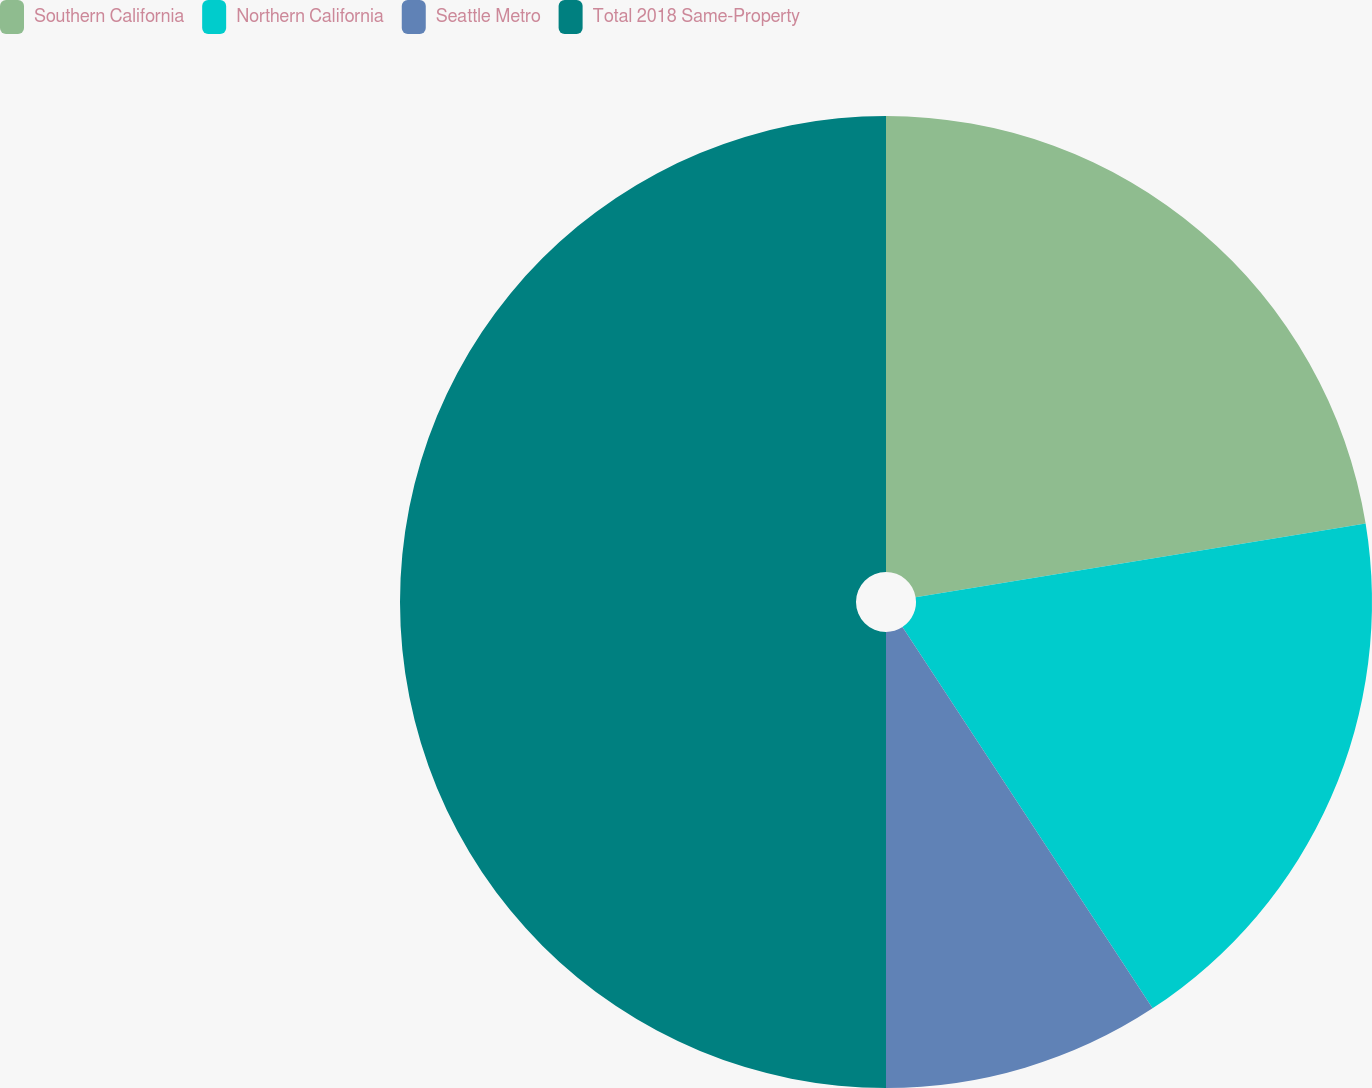Convert chart. <chart><loc_0><loc_0><loc_500><loc_500><pie_chart><fcel>Southern California<fcel>Northern California<fcel>Seattle Metro<fcel>Total 2018 Same-Property<nl><fcel>22.42%<fcel>18.34%<fcel>9.24%<fcel>50.0%<nl></chart> 